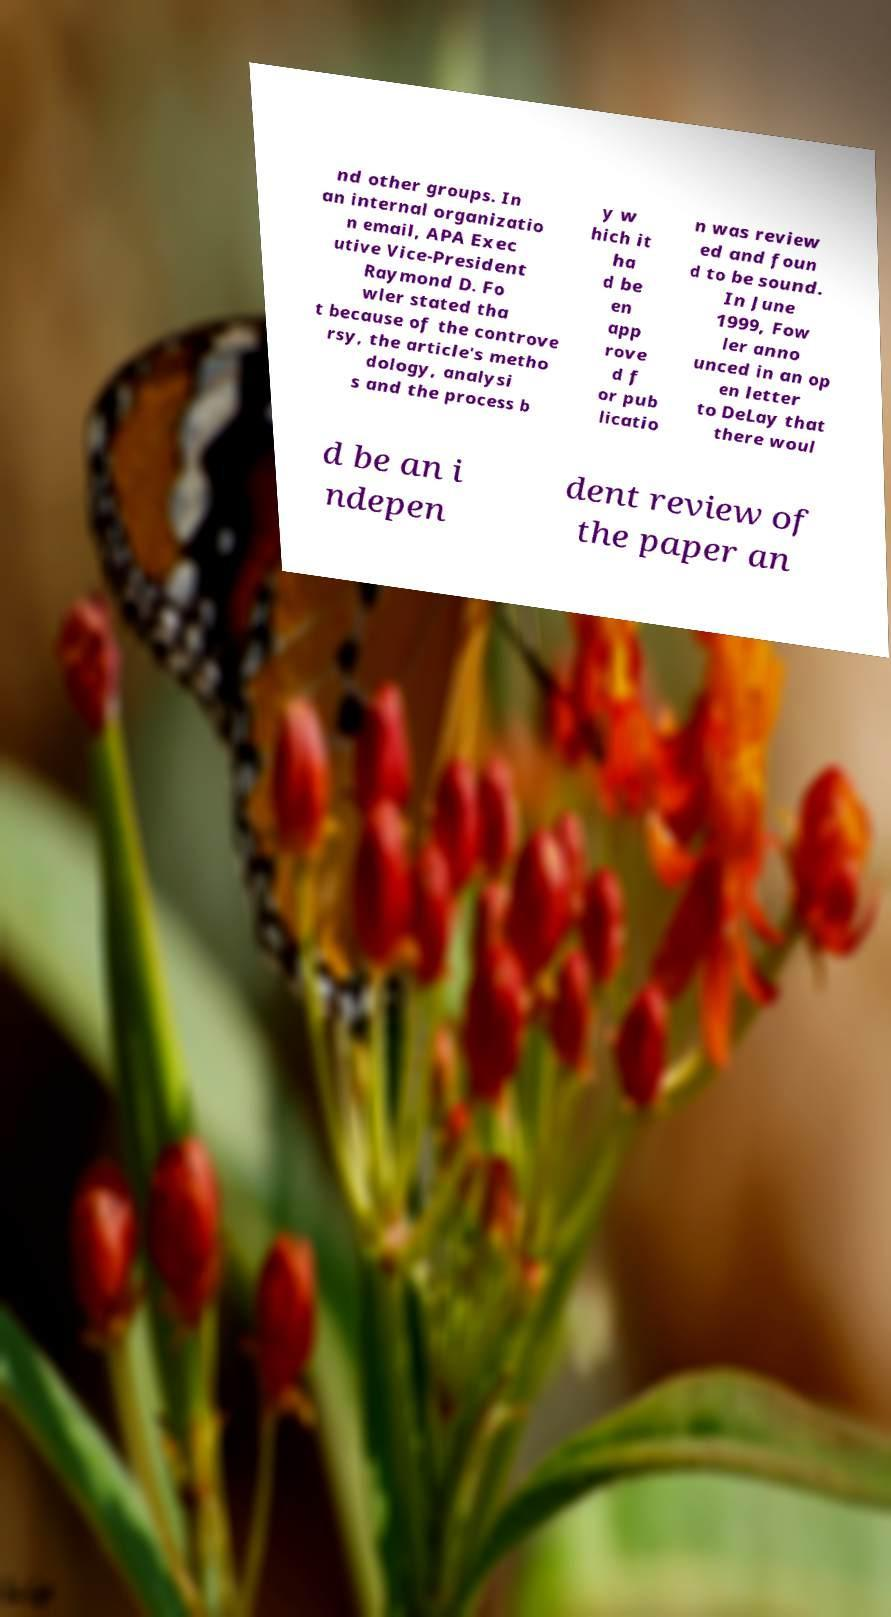For documentation purposes, I need the text within this image transcribed. Could you provide that? nd other groups. In an internal organizatio n email, APA Exec utive Vice-President Raymond D. Fo wler stated tha t because of the controve rsy, the article's metho dology, analysi s and the process b y w hich it ha d be en app rove d f or pub licatio n was review ed and foun d to be sound. In June 1999, Fow ler anno unced in an op en letter to DeLay that there woul d be an i ndepen dent review of the paper an 